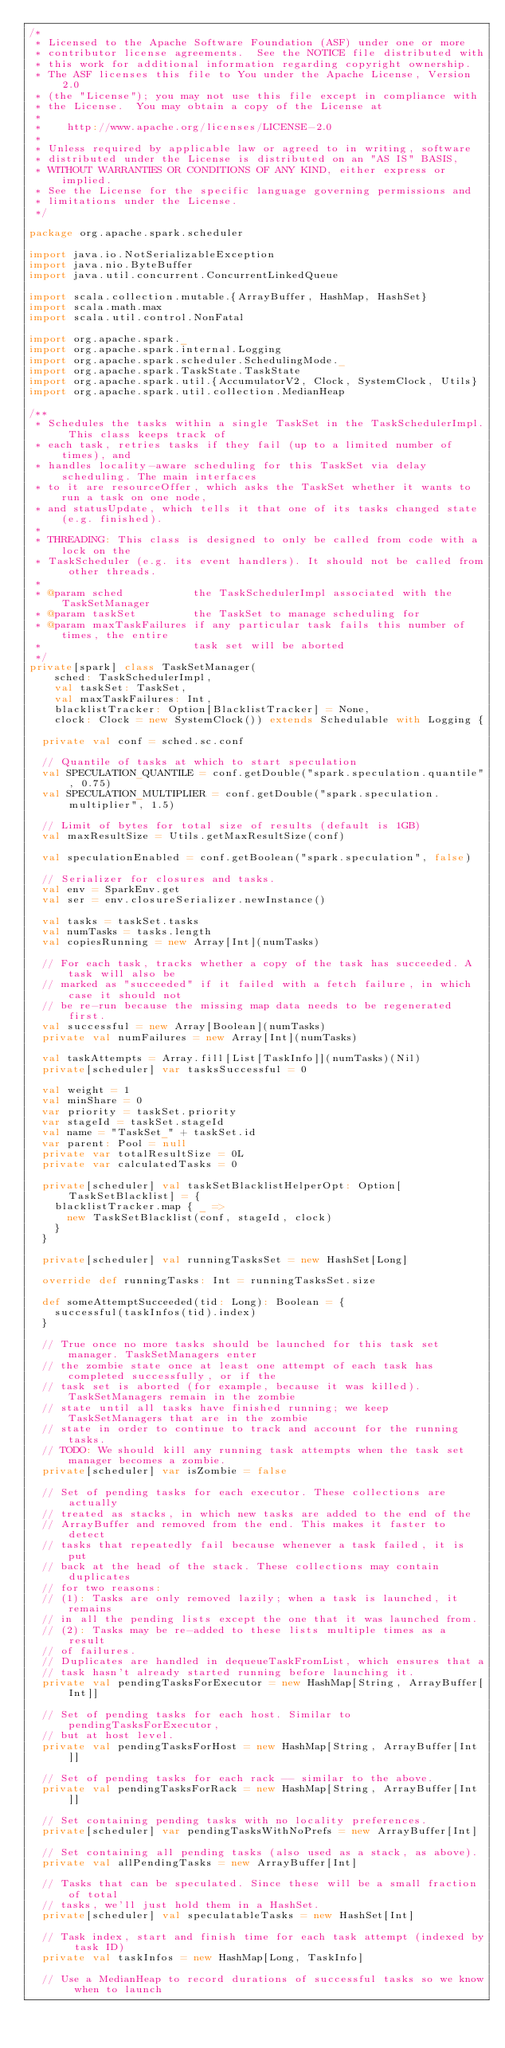Convert code to text. <code><loc_0><loc_0><loc_500><loc_500><_Scala_>/*
 * Licensed to the Apache Software Foundation (ASF) under one or more
 * contributor license agreements.  See the NOTICE file distributed with
 * this work for additional information regarding copyright ownership.
 * The ASF licenses this file to You under the Apache License, Version 2.0
 * (the "License"); you may not use this file except in compliance with
 * the License.  You may obtain a copy of the License at
 *
 *    http://www.apache.org/licenses/LICENSE-2.0
 *
 * Unless required by applicable law or agreed to in writing, software
 * distributed under the License is distributed on an "AS IS" BASIS,
 * WITHOUT WARRANTIES OR CONDITIONS OF ANY KIND, either express or implied.
 * See the License for the specific language governing permissions and
 * limitations under the License.
 */

package org.apache.spark.scheduler

import java.io.NotSerializableException
import java.nio.ByteBuffer
import java.util.concurrent.ConcurrentLinkedQueue

import scala.collection.mutable.{ArrayBuffer, HashMap, HashSet}
import scala.math.max
import scala.util.control.NonFatal

import org.apache.spark._
import org.apache.spark.internal.Logging
import org.apache.spark.scheduler.SchedulingMode._
import org.apache.spark.TaskState.TaskState
import org.apache.spark.util.{AccumulatorV2, Clock, SystemClock, Utils}
import org.apache.spark.util.collection.MedianHeap

/**
 * Schedules the tasks within a single TaskSet in the TaskSchedulerImpl. This class keeps track of
 * each task, retries tasks if they fail (up to a limited number of times), and
 * handles locality-aware scheduling for this TaskSet via delay scheduling. The main interfaces
 * to it are resourceOffer, which asks the TaskSet whether it wants to run a task on one node,
 * and statusUpdate, which tells it that one of its tasks changed state (e.g. finished).
 *
 * THREADING: This class is designed to only be called from code with a lock on the
 * TaskScheduler (e.g. its event handlers). It should not be called from other threads.
 *
 * @param sched           the TaskSchedulerImpl associated with the TaskSetManager
 * @param taskSet         the TaskSet to manage scheduling for
 * @param maxTaskFailures if any particular task fails this number of times, the entire
 *                        task set will be aborted
 */
private[spark] class TaskSetManager(
    sched: TaskSchedulerImpl,
    val taskSet: TaskSet,
    val maxTaskFailures: Int,
    blacklistTracker: Option[BlacklistTracker] = None,
    clock: Clock = new SystemClock()) extends Schedulable with Logging {

  private val conf = sched.sc.conf

  // Quantile of tasks at which to start speculation
  val SPECULATION_QUANTILE = conf.getDouble("spark.speculation.quantile", 0.75)
  val SPECULATION_MULTIPLIER = conf.getDouble("spark.speculation.multiplier", 1.5)

  // Limit of bytes for total size of results (default is 1GB)
  val maxResultSize = Utils.getMaxResultSize(conf)

  val speculationEnabled = conf.getBoolean("spark.speculation", false)

  // Serializer for closures and tasks.
  val env = SparkEnv.get
  val ser = env.closureSerializer.newInstance()

  val tasks = taskSet.tasks
  val numTasks = tasks.length
  val copiesRunning = new Array[Int](numTasks)

  // For each task, tracks whether a copy of the task has succeeded. A task will also be
  // marked as "succeeded" if it failed with a fetch failure, in which case it should not
  // be re-run because the missing map data needs to be regenerated first.
  val successful = new Array[Boolean](numTasks)
  private val numFailures = new Array[Int](numTasks)

  val taskAttempts = Array.fill[List[TaskInfo]](numTasks)(Nil)
  private[scheduler] var tasksSuccessful = 0

  val weight = 1
  val minShare = 0
  var priority = taskSet.priority
  var stageId = taskSet.stageId
  val name = "TaskSet_" + taskSet.id
  var parent: Pool = null
  private var totalResultSize = 0L
  private var calculatedTasks = 0

  private[scheduler] val taskSetBlacklistHelperOpt: Option[TaskSetBlacklist] = {
    blacklistTracker.map { _ =>
      new TaskSetBlacklist(conf, stageId, clock)
    }
  }

  private[scheduler] val runningTasksSet = new HashSet[Long]

  override def runningTasks: Int = runningTasksSet.size

  def someAttemptSucceeded(tid: Long): Boolean = {
    successful(taskInfos(tid).index)
  }

  // True once no more tasks should be launched for this task set manager. TaskSetManagers enter
  // the zombie state once at least one attempt of each task has completed successfully, or if the
  // task set is aborted (for example, because it was killed).  TaskSetManagers remain in the zombie
  // state until all tasks have finished running; we keep TaskSetManagers that are in the zombie
  // state in order to continue to track and account for the running tasks.
  // TODO: We should kill any running task attempts when the task set manager becomes a zombie.
  private[scheduler] var isZombie = false

  // Set of pending tasks for each executor. These collections are actually
  // treated as stacks, in which new tasks are added to the end of the
  // ArrayBuffer and removed from the end. This makes it faster to detect
  // tasks that repeatedly fail because whenever a task failed, it is put
  // back at the head of the stack. These collections may contain duplicates
  // for two reasons:
  // (1): Tasks are only removed lazily; when a task is launched, it remains
  // in all the pending lists except the one that it was launched from.
  // (2): Tasks may be re-added to these lists multiple times as a result
  // of failures.
  // Duplicates are handled in dequeueTaskFromList, which ensures that a
  // task hasn't already started running before launching it.
  private val pendingTasksForExecutor = new HashMap[String, ArrayBuffer[Int]]

  // Set of pending tasks for each host. Similar to pendingTasksForExecutor,
  // but at host level.
  private val pendingTasksForHost = new HashMap[String, ArrayBuffer[Int]]

  // Set of pending tasks for each rack -- similar to the above.
  private val pendingTasksForRack = new HashMap[String, ArrayBuffer[Int]]

  // Set containing pending tasks with no locality preferences.
  private[scheduler] var pendingTasksWithNoPrefs = new ArrayBuffer[Int]

  // Set containing all pending tasks (also used as a stack, as above).
  private val allPendingTasks = new ArrayBuffer[Int]

  // Tasks that can be speculated. Since these will be a small fraction of total
  // tasks, we'll just hold them in a HashSet.
  private[scheduler] val speculatableTasks = new HashSet[Int]

  // Task index, start and finish time for each task attempt (indexed by task ID)
  private val taskInfos = new HashMap[Long, TaskInfo]

  // Use a MedianHeap to record durations of successful tasks so we know when to launch</code> 